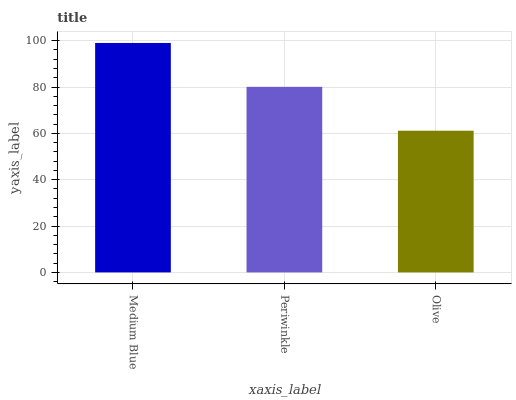Is Periwinkle the minimum?
Answer yes or no. No. Is Periwinkle the maximum?
Answer yes or no. No. Is Medium Blue greater than Periwinkle?
Answer yes or no. Yes. Is Periwinkle less than Medium Blue?
Answer yes or no. Yes. Is Periwinkle greater than Medium Blue?
Answer yes or no. No. Is Medium Blue less than Periwinkle?
Answer yes or no. No. Is Periwinkle the high median?
Answer yes or no. Yes. Is Periwinkle the low median?
Answer yes or no. Yes. Is Medium Blue the high median?
Answer yes or no. No. Is Medium Blue the low median?
Answer yes or no. No. 